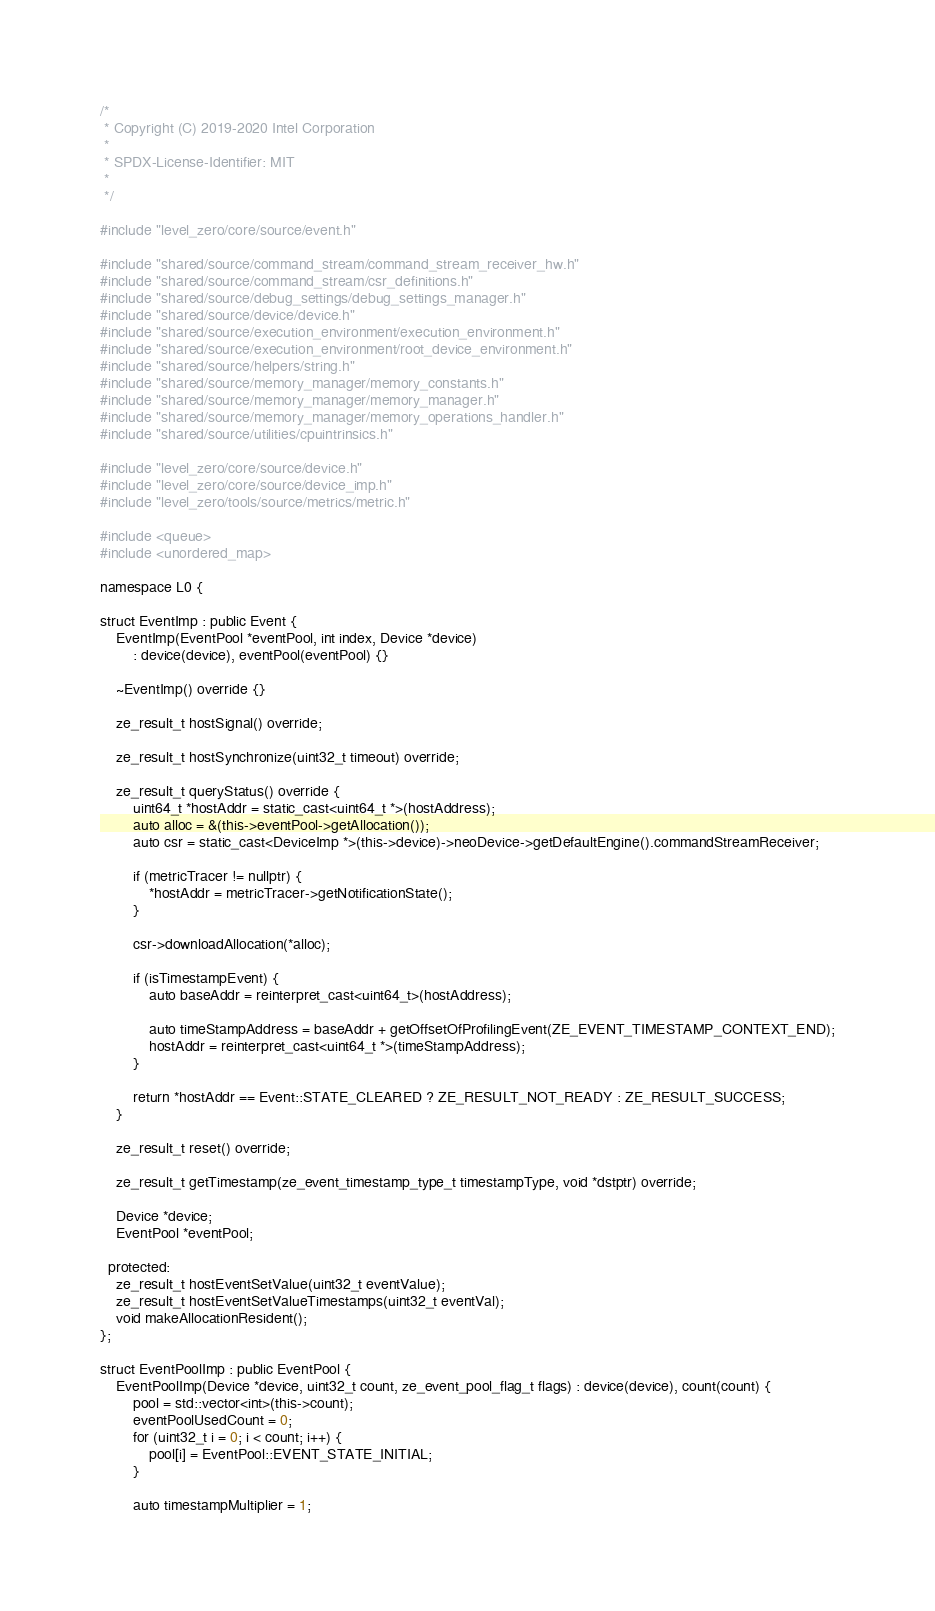<code> <loc_0><loc_0><loc_500><loc_500><_C++_>/*
 * Copyright (C) 2019-2020 Intel Corporation
 *
 * SPDX-License-Identifier: MIT
 *
 */

#include "level_zero/core/source/event.h"

#include "shared/source/command_stream/command_stream_receiver_hw.h"
#include "shared/source/command_stream/csr_definitions.h"
#include "shared/source/debug_settings/debug_settings_manager.h"
#include "shared/source/device/device.h"
#include "shared/source/execution_environment/execution_environment.h"
#include "shared/source/execution_environment/root_device_environment.h"
#include "shared/source/helpers/string.h"
#include "shared/source/memory_manager/memory_constants.h"
#include "shared/source/memory_manager/memory_manager.h"
#include "shared/source/memory_manager/memory_operations_handler.h"
#include "shared/source/utilities/cpuintrinsics.h"

#include "level_zero/core/source/device.h"
#include "level_zero/core/source/device_imp.h"
#include "level_zero/tools/source/metrics/metric.h"

#include <queue>
#include <unordered_map>

namespace L0 {

struct EventImp : public Event {
    EventImp(EventPool *eventPool, int index, Device *device)
        : device(device), eventPool(eventPool) {}

    ~EventImp() override {}

    ze_result_t hostSignal() override;

    ze_result_t hostSynchronize(uint32_t timeout) override;

    ze_result_t queryStatus() override {
        uint64_t *hostAddr = static_cast<uint64_t *>(hostAddress);
        auto alloc = &(this->eventPool->getAllocation());
        auto csr = static_cast<DeviceImp *>(this->device)->neoDevice->getDefaultEngine().commandStreamReceiver;

        if (metricTracer != nullptr) {
            *hostAddr = metricTracer->getNotificationState();
        }

        csr->downloadAllocation(*alloc);

        if (isTimestampEvent) {
            auto baseAddr = reinterpret_cast<uint64_t>(hostAddress);

            auto timeStampAddress = baseAddr + getOffsetOfProfilingEvent(ZE_EVENT_TIMESTAMP_CONTEXT_END);
            hostAddr = reinterpret_cast<uint64_t *>(timeStampAddress);
        }

        return *hostAddr == Event::STATE_CLEARED ? ZE_RESULT_NOT_READY : ZE_RESULT_SUCCESS;
    }

    ze_result_t reset() override;

    ze_result_t getTimestamp(ze_event_timestamp_type_t timestampType, void *dstptr) override;

    Device *device;
    EventPool *eventPool;

  protected:
    ze_result_t hostEventSetValue(uint32_t eventValue);
    ze_result_t hostEventSetValueTimestamps(uint32_t eventVal);
    void makeAllocationResident();
};

struct EventPoolImp : public EventPool {
    EventPoolImp(Device *device, uint32_t count, ze_event_pool_flag_t flags) : device(device), count(count) {
        pool = std::vector<int>(this->count);
        eventPoolUsedCount = 0;
        for (uint32_t i = 0; i < count; i++) {
            pool[i] = EventPool::EVENT_STATE_INITIAL;
        }

        auto timestampMultiplier = 1;</code> 